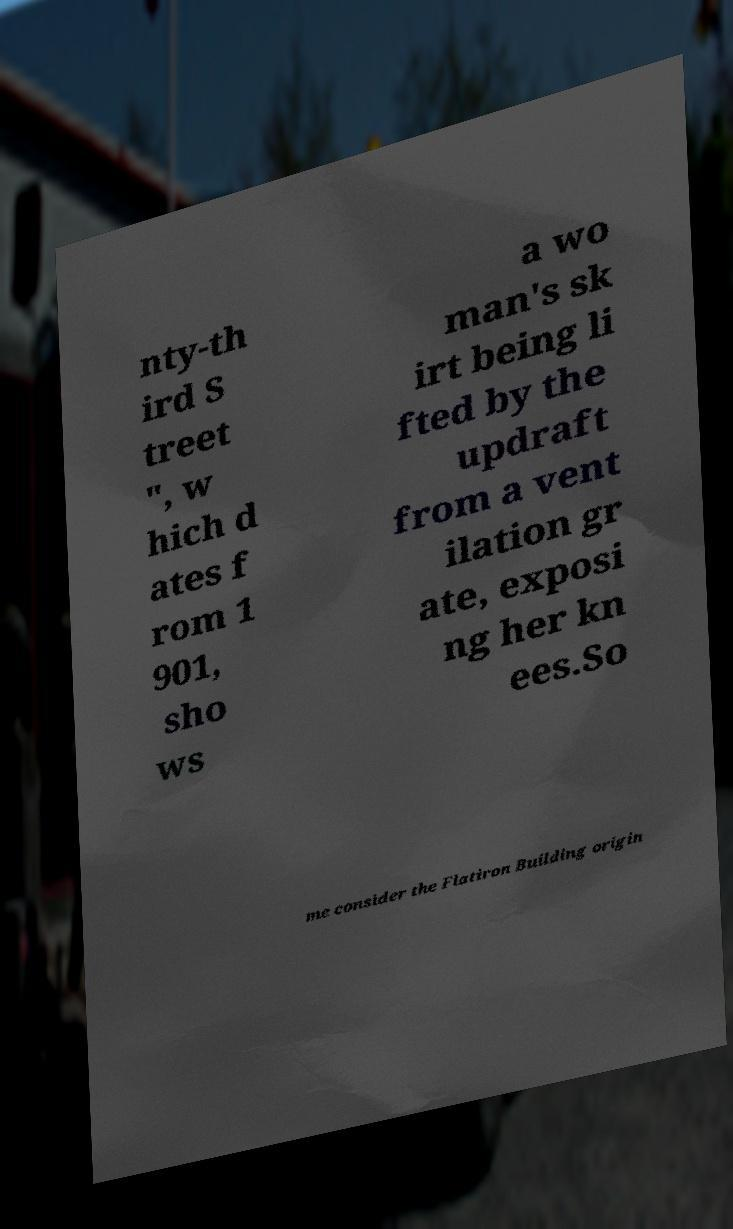Can you read and provide the text displayed in the image?This photo seems to have some interesting text. Can you extract and type it out for me? nty-th ird S treet ", w hich d ates f rom 1 901, sho ws a wo man's sk irt being li fted by the updraft from a vent ilation gr ate, exposi ng her kn ees.So me consider the Flatiron Building origin 